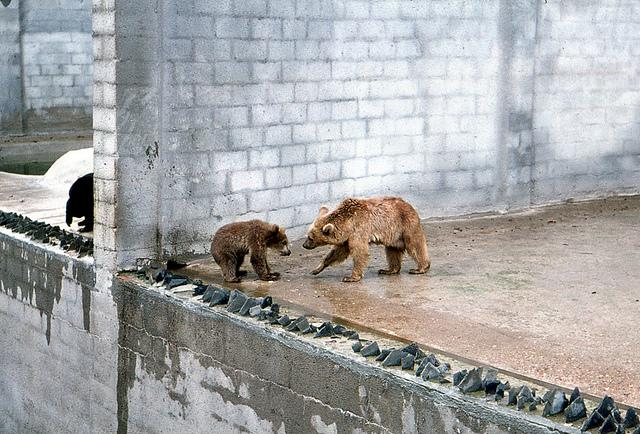What type of bears are in the foreground? brown bears 